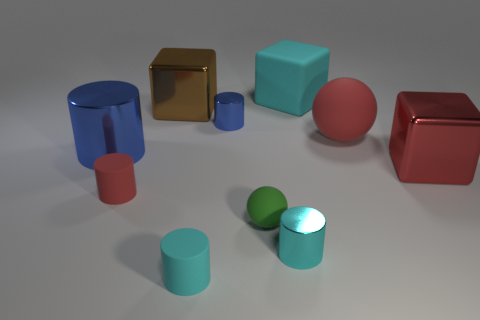How many cyan cylinders must be subtracted to get 1 cyan cylinders? 1 Subtract all brown cubes. How many cubes are left? 2 Subtract all red metal blocks. How many blocks are left? 2 Subtract 0 gray cylinders. How many objects are left? 10 Subtract all spheres. How many objects are left? 8 Subtract 2 cylinders. How many cylinders are left? 3 Subtract all purple blocks. Subtract all yellow cylinders. How many blocks are left? 3 Subtract all blue cylinders. How many green balls are left? 1 Subtract all large cyan balls. Subtract all green balls. How many objects are left? 9 Add 2 brown shiny cubes. How many brown shiny cubes are left? 3 